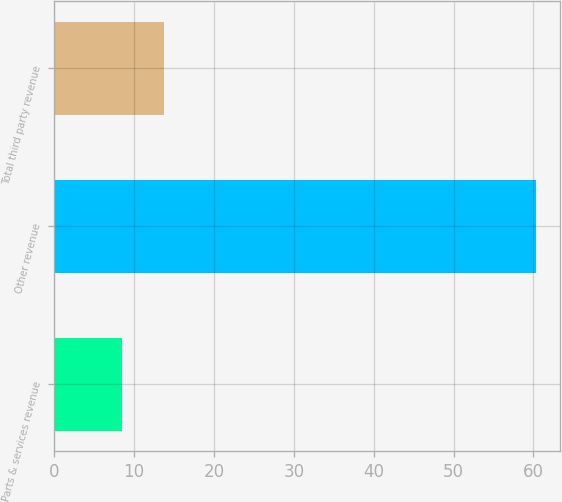Convert chart. <chart><loc_0><loc_0><loc_500><loc_500><bar_chart><fcel>Parts & services revenue<fcel>Other revenue<fcel>Total third party revenue<nl><fcel>8.5<fcel>60.3<fcel>13.68<nl></chart> 